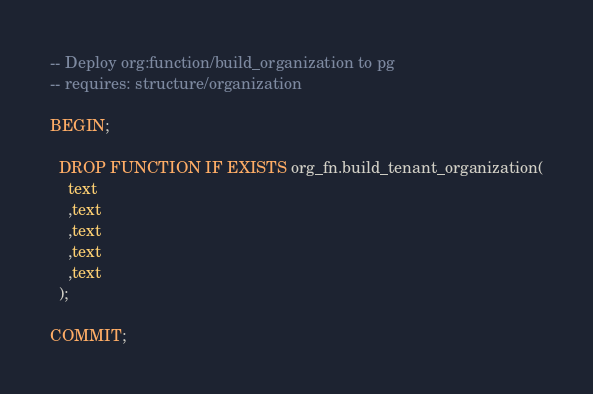<code> <loc_0><loc_0><loc_500><loc_500><_SQL_>-- Deploy org:function/build_organization to pg
-- requires: structure/organization

BEGIN;

  DROP FUNCTION IF EXISTS org_fn.build_tenant_organization(
    text
    ,text
    ,text
    ,text
    ,text
  );

COMMIT;
</code> 